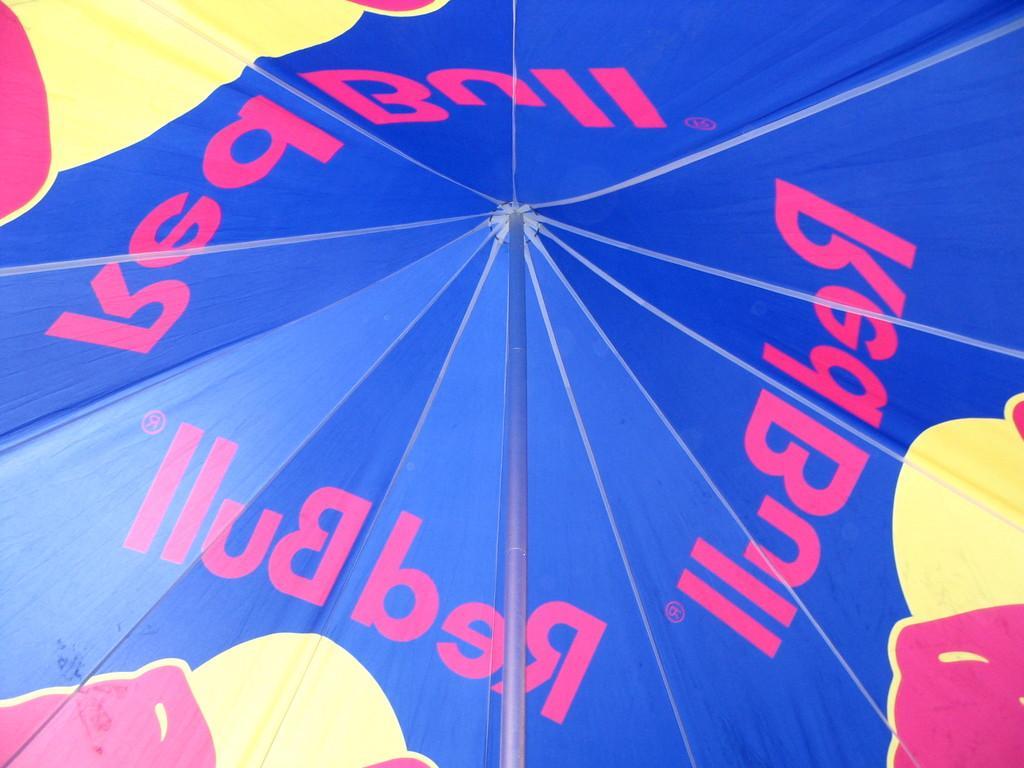In one or two sentences, can you explain what this image depicts? In this picture I can see a tent with pole. 